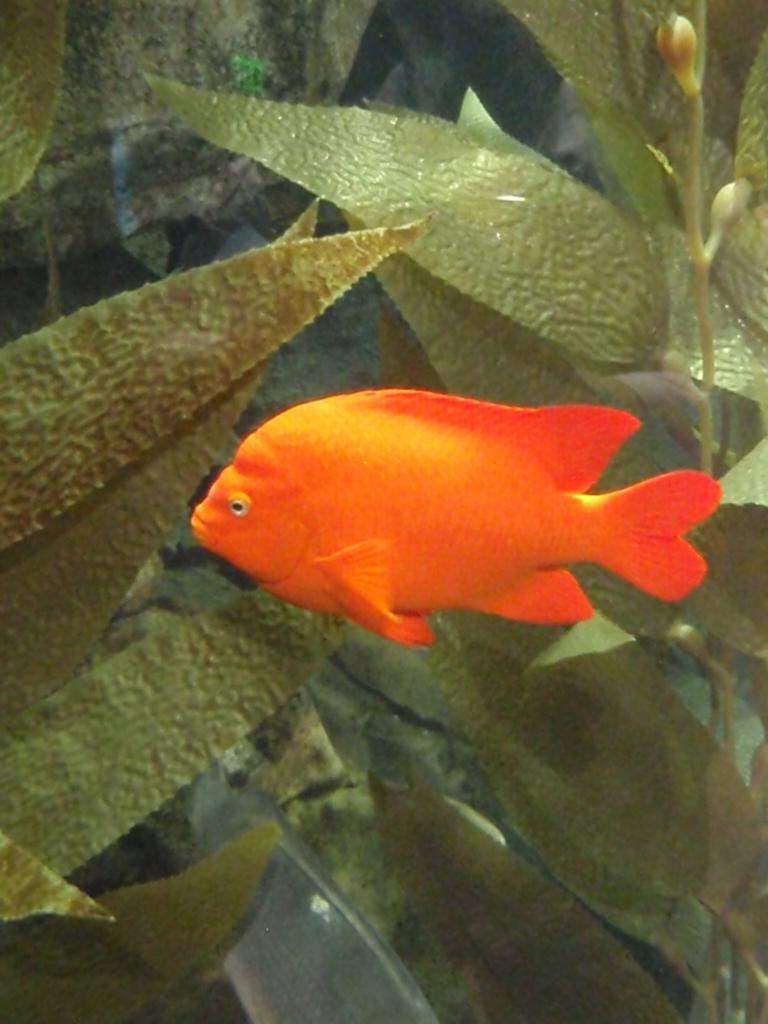What type of animals can be seen in the image? There are fish in the image. What else is present in the water in the image? There are plants in the water in the image. What type of servant can be seen in the image? There is no servant present in the image; it features fish and plants in the water. What type of advertisement is displayed in the image? There is no advertisement present in the image; it features fish and plants in the water. 